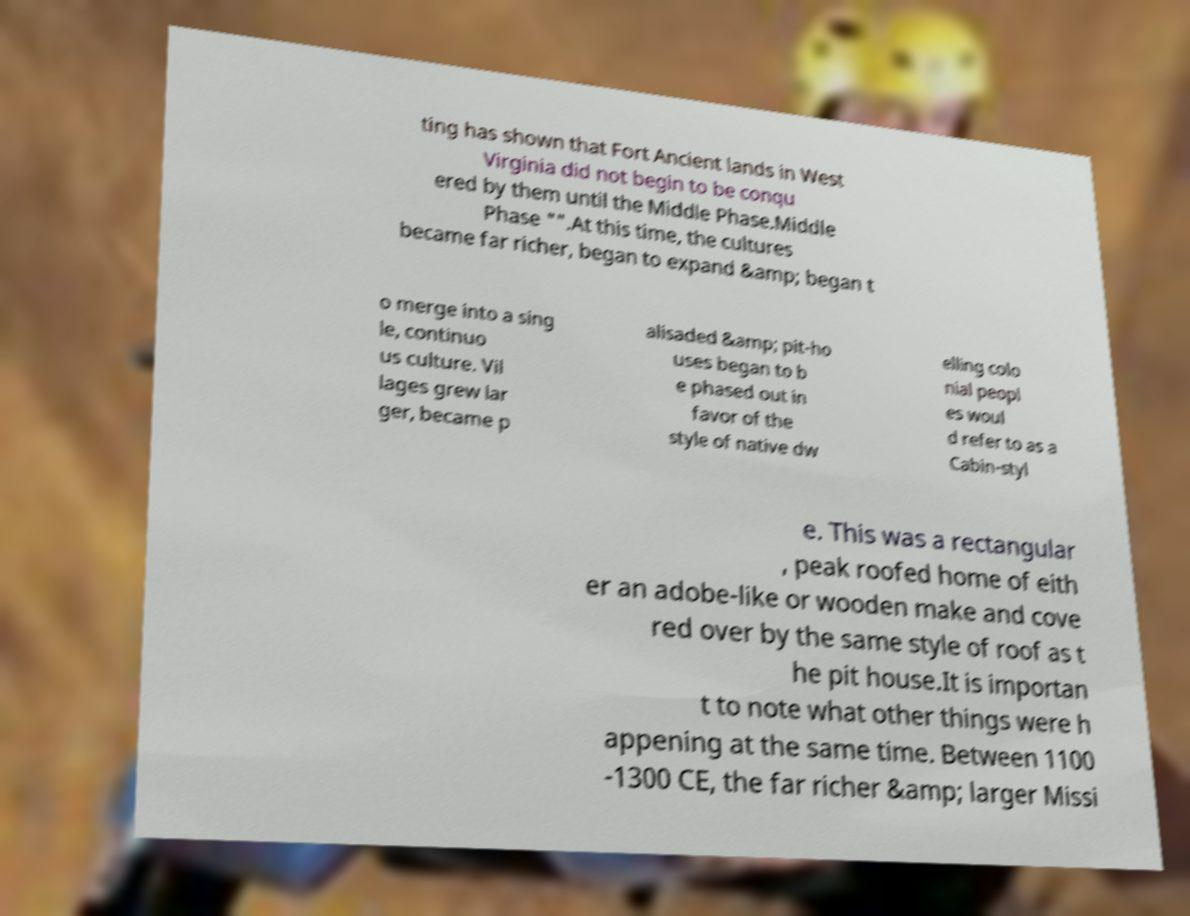Could you extract and type out the text from this image? ting has shown that Fort Ancient lands in West Virginia did not begin to be conqu ered by them until the Middle Phase.Middle Phase "".At this time, the cultures became far richer, began to expand &amp; began t o merge into a sing le, continuo us culture. Vil lages grew lar ger, became p alisaded &amp; pit-ho uses began to b e phased out in favor of the style of native dw elling colo nial peopl es woul d refer to as a Cabin-styl e. This was a rectangular , peak roofed home of eith er an adobe-like or wooden make and cove red over by the same style of roof as t he pit house.It is importan t to note what other things were h appening at the same time. Between 1100 -1300 CE, the far richer &amp; larger Missi 